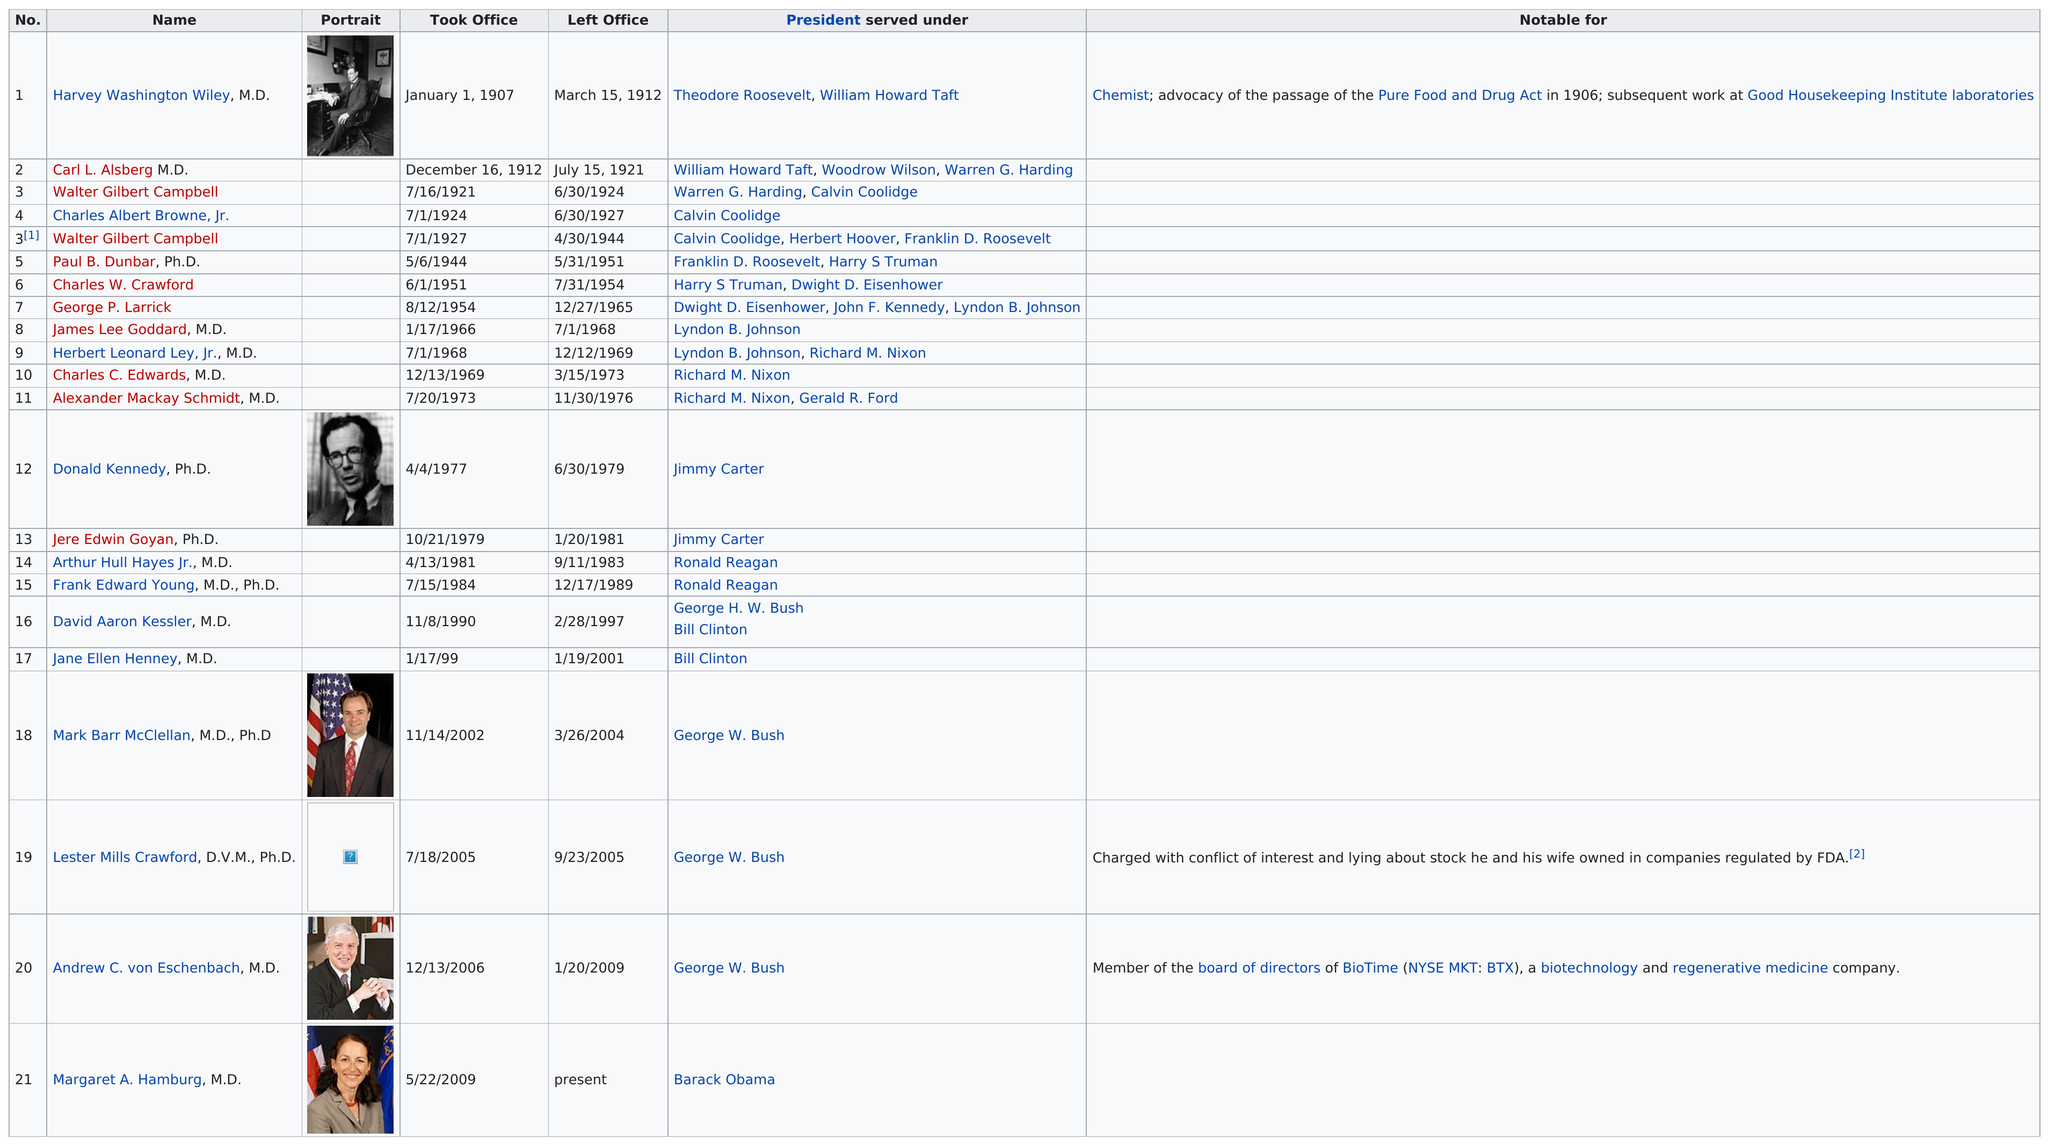Specify some key components in this picture. Lester Mills Crawford, D.V.M., Ph.D., held the office for the shortest amount of time. Walter Gilbert Campbell served as the longest-serving Mayor in the history of the city. During Calvin Coolidge's presidency, three commissioners served under him. During the administration of George W. Bush, a total of four commissioners of the Food and Drug Administration were appointed. There have been 21 commissioners. 